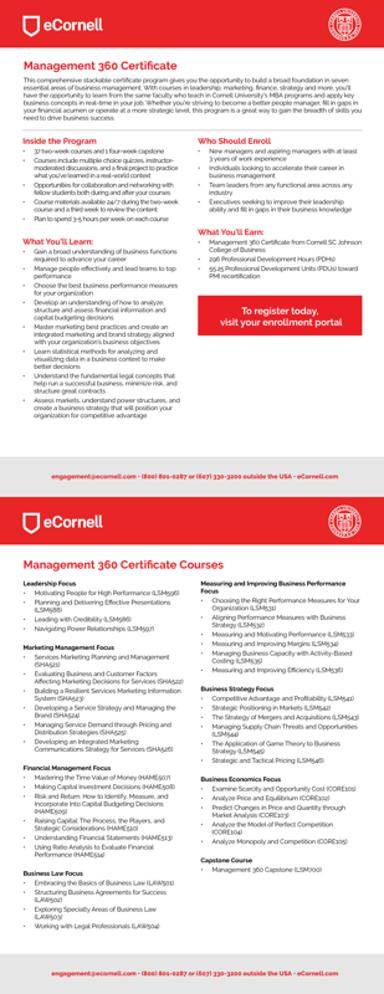Who is the ideal candidate for the eCornell Management 360 Certificate program? The ideal candidate for the eCornell Management 360 Certificate program includes new managers and aspiring leaders seeking to lay a strong foundation in management functions. It's also suitable for seasoned managers looking to update their skills and knowledge in specific business areas. 